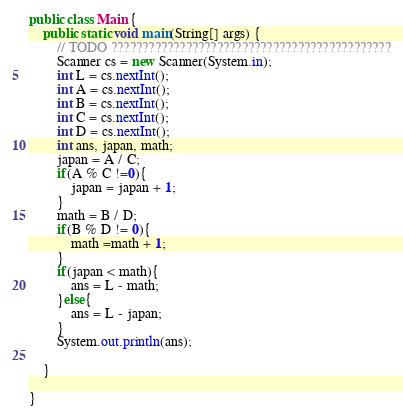Convert code to text. <code><loc_0><loc_0><loc_500><loc_500><_Java_>public class Main {
	public static void main(String[] args) {
		// TODO ?????????????????????????????????????????????
		Scanner cs = new Scanner(System.in);
		int L = cs.nextInt();
		int A = cs.nextInt();
		int B = cs.nextInt();
		int C = cs.nextInt();
		int D = cs.nextInt();
		int ans, japan, math;
		japan = A / C;
		if(A % C !=0){
			japan = japan + 1;
		}
		math = B / D;
		if(B % D != 0){
			math =math + 1;
		}
		if(japan < math){
			ans = L - math;
		}else{
			ans = L - japan;
		}
		System.out.println(ans);

	}

}</code> 